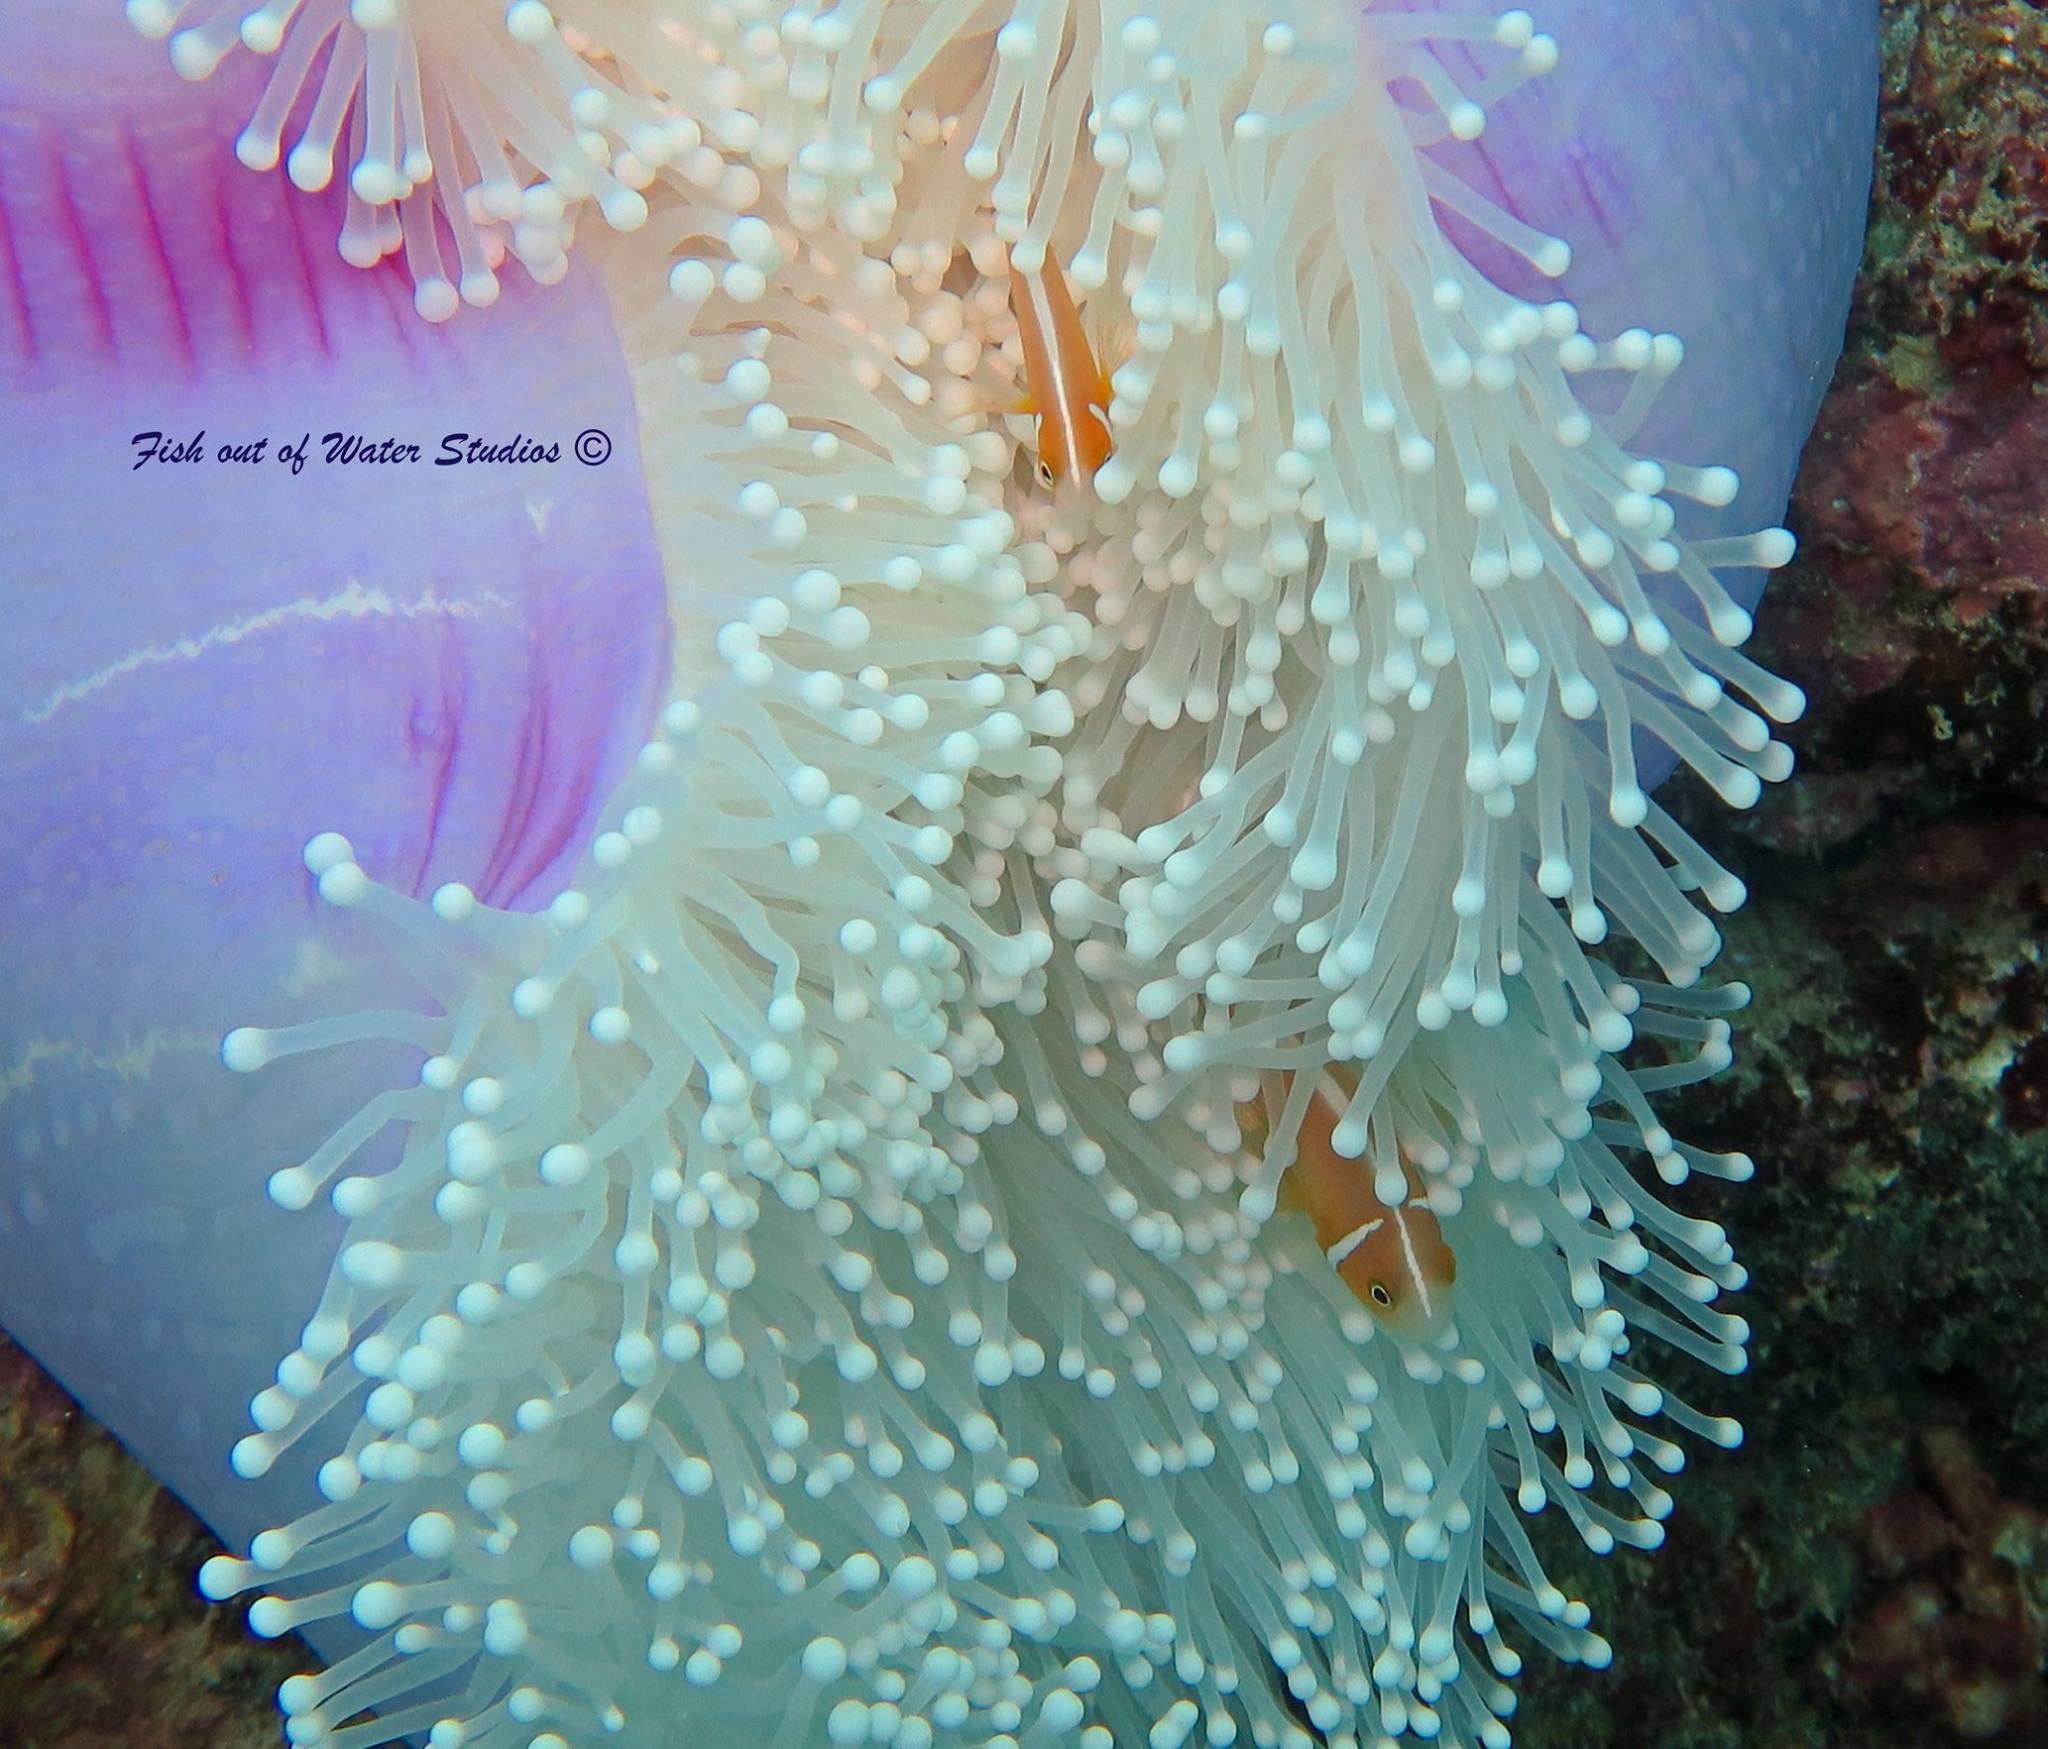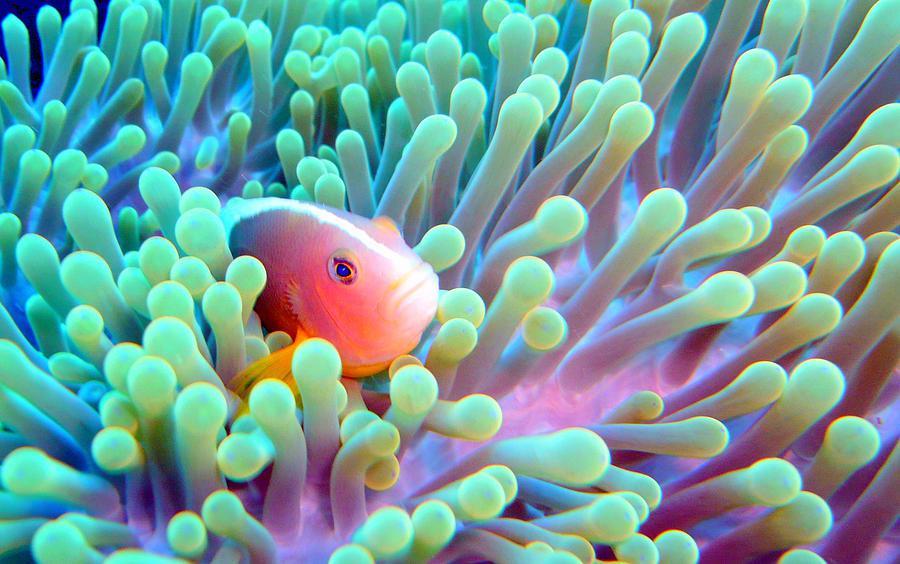The first image is the image on the left, the second image is the image on the right. Given the left and right images, does the statement "The left image contains a single fish." hold true? Answer yes or no. No. 